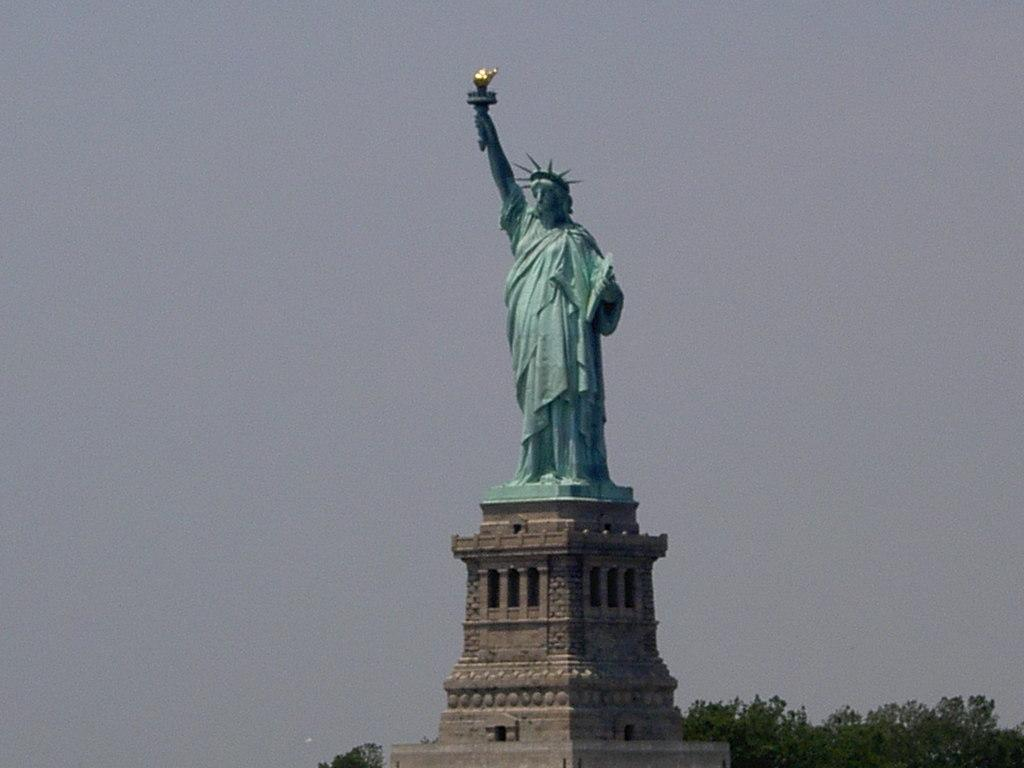What famous monument can be seen in the image? The Statue of Liberty is on a monument in the image. What type of natural environment is visible in the background of the image? There are many trees in the background of the image. What is visible at the top of the image? The sky is visible at the top of the image. What type of plantation can be seen in the image? There is no plantation present in the image; it features the Statue of Liberty on a monument with trees in the background and the sky visible at the top. 